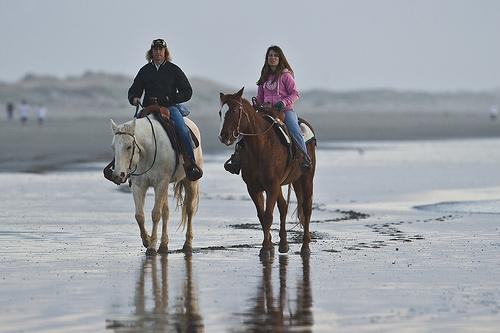What are some notable details about the woman and the horse she is riding? The woman has long brown hair, wears a pink and white jacket, blue pants, and is riding a brown horse with a white forehead on the beach. What is the scene in the background of the image? There are three people in the distance on the beach, one wearing a blue shirt, and a big brown mountain in the background. What color is the woman's jacket and what is she doing in the image? The woman's jacket is pink, and she is riding a brown horse on the beach. Describe the colors and the condition of the sky in the image. The sky is light blue with the presence of few clouds. Describe the horses in the image in terms of their color and the terrain they are walking on. There is a white horse ridden by a man and a brown horse with a white forehead ridden by a woman, both walking through water on a wet beach. Mention the attire of both horse riders and the characteristics of the horses they are riding. The man wears a black jacket, blue jeans, and a black and yellow cap, and is riding a mostly white horse. The woman wears a pink and white jacket, blue pants, and is riding a primarily brown horse with a white forehead. What can be observed about the beach environment in the image? The sand is wet and grey, and there are hoofprints on the wet beach, along with reflections of horses on the sand and smooth water. Can you describe the appearance of the man and what he is doing in the image? The man has slightly long hair, wears a black jacket, blue jeans, and a black and yellow cap, and is riding a white horse on the beach. What is the main action taking place on the beach in the image? The main action is two people riding horses along the water's edge on a beach, with the horses walking through water. Identify the activity taking place on the image and describe the participants. Two people, a man wearing a cap and a woman with a pink jacket, are riding horses on a beach, with the man on a white horse and the woman on a brown horse. 